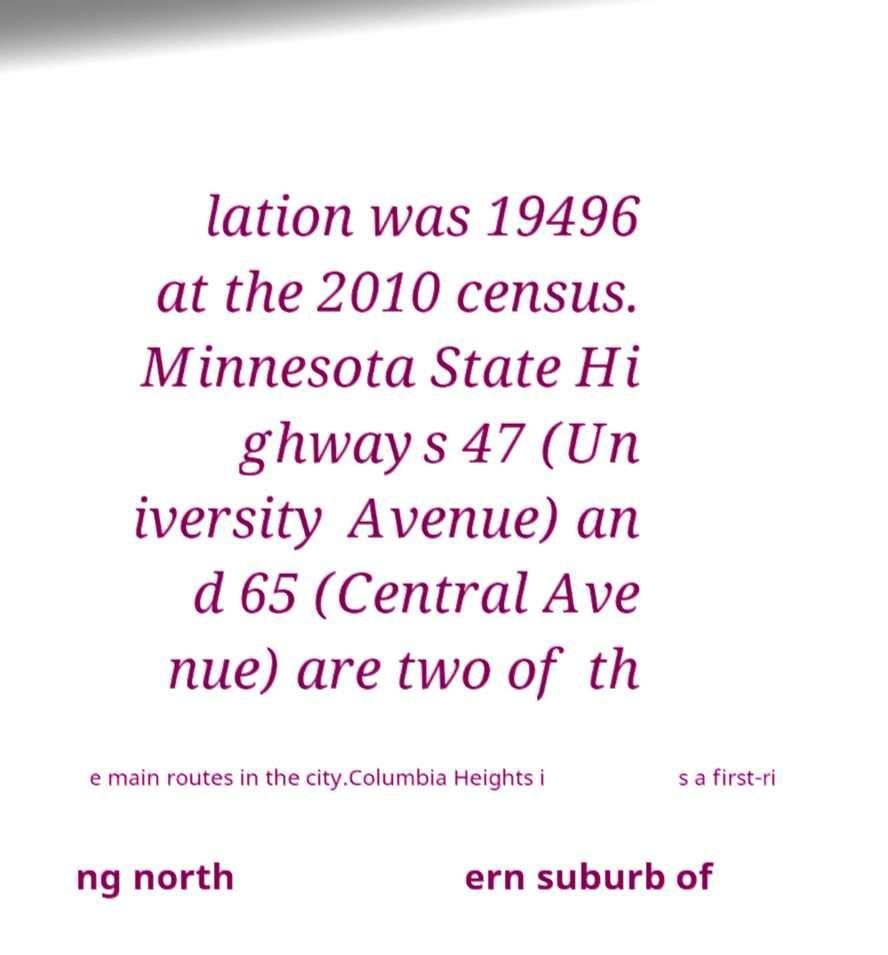Could you extract and type out the text from this image? lation was 19496 at the 2010 census. Minnesota State Hi ghways 47 (Un iversity Avenue) an d 65 (Central Ave nue) are two of th e main routes in the city.Columbia Heights i s a first-ri ng north ern suburb of 